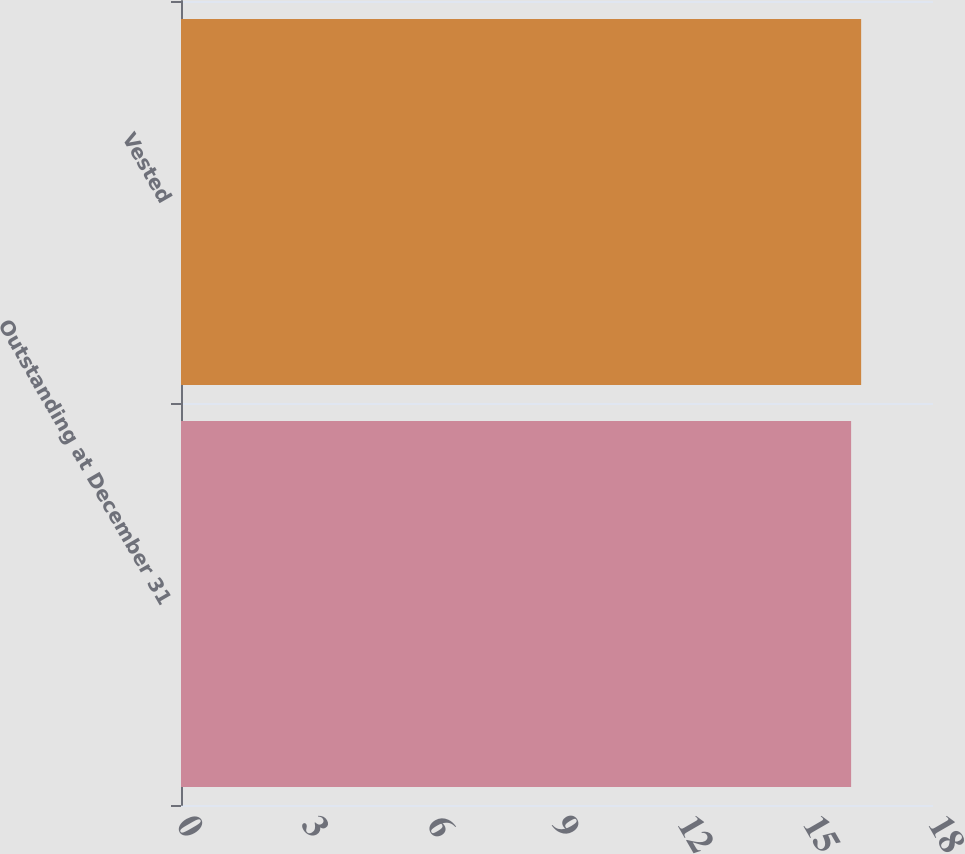Convert chart. <chart><loc_0><loc_0><loc_500><loc_500><bar_chart><fcel>Outstanding at December 31<fcel>Vested<nl><fcel>16.04<fcel>16.28<nl></chart> 